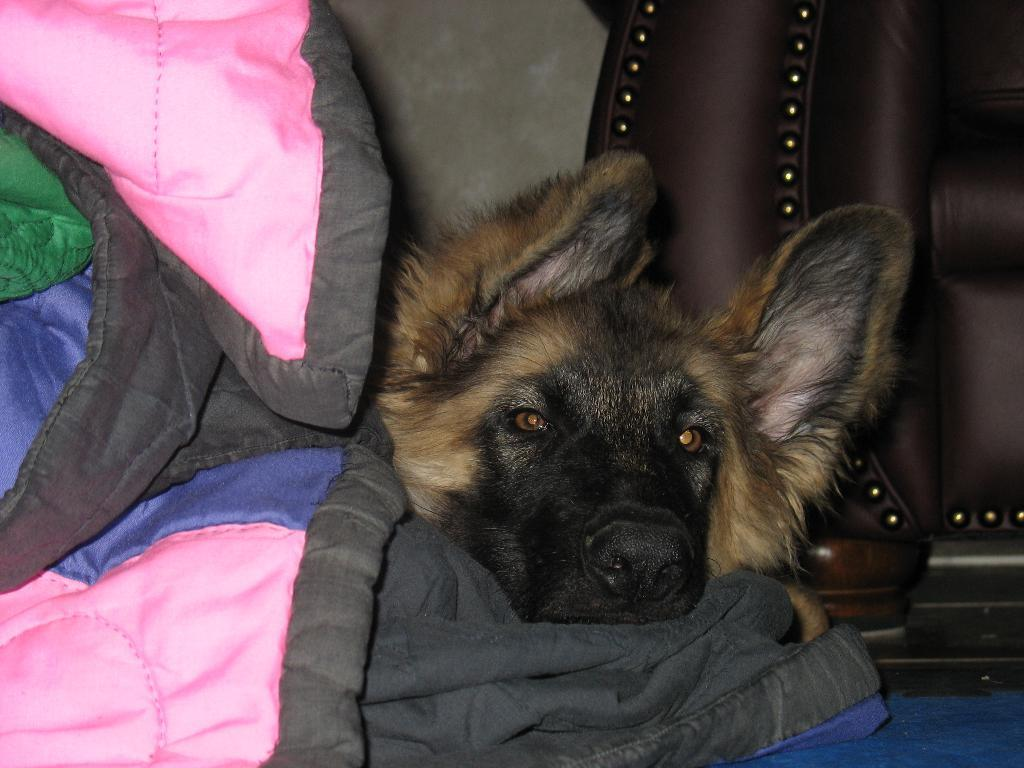What animal is in the middle of the image? There is a dog in the middle of the image. What can be seen on the left side of the image? There are clothes on the left side of the image. What type of object is on the right side of the image? There is a wooden object on the right side of the image. Where is the brain located in the image? There is no brain present in the image. What type of hydrant can be seen in the image? There is no hydrant present in the image. 